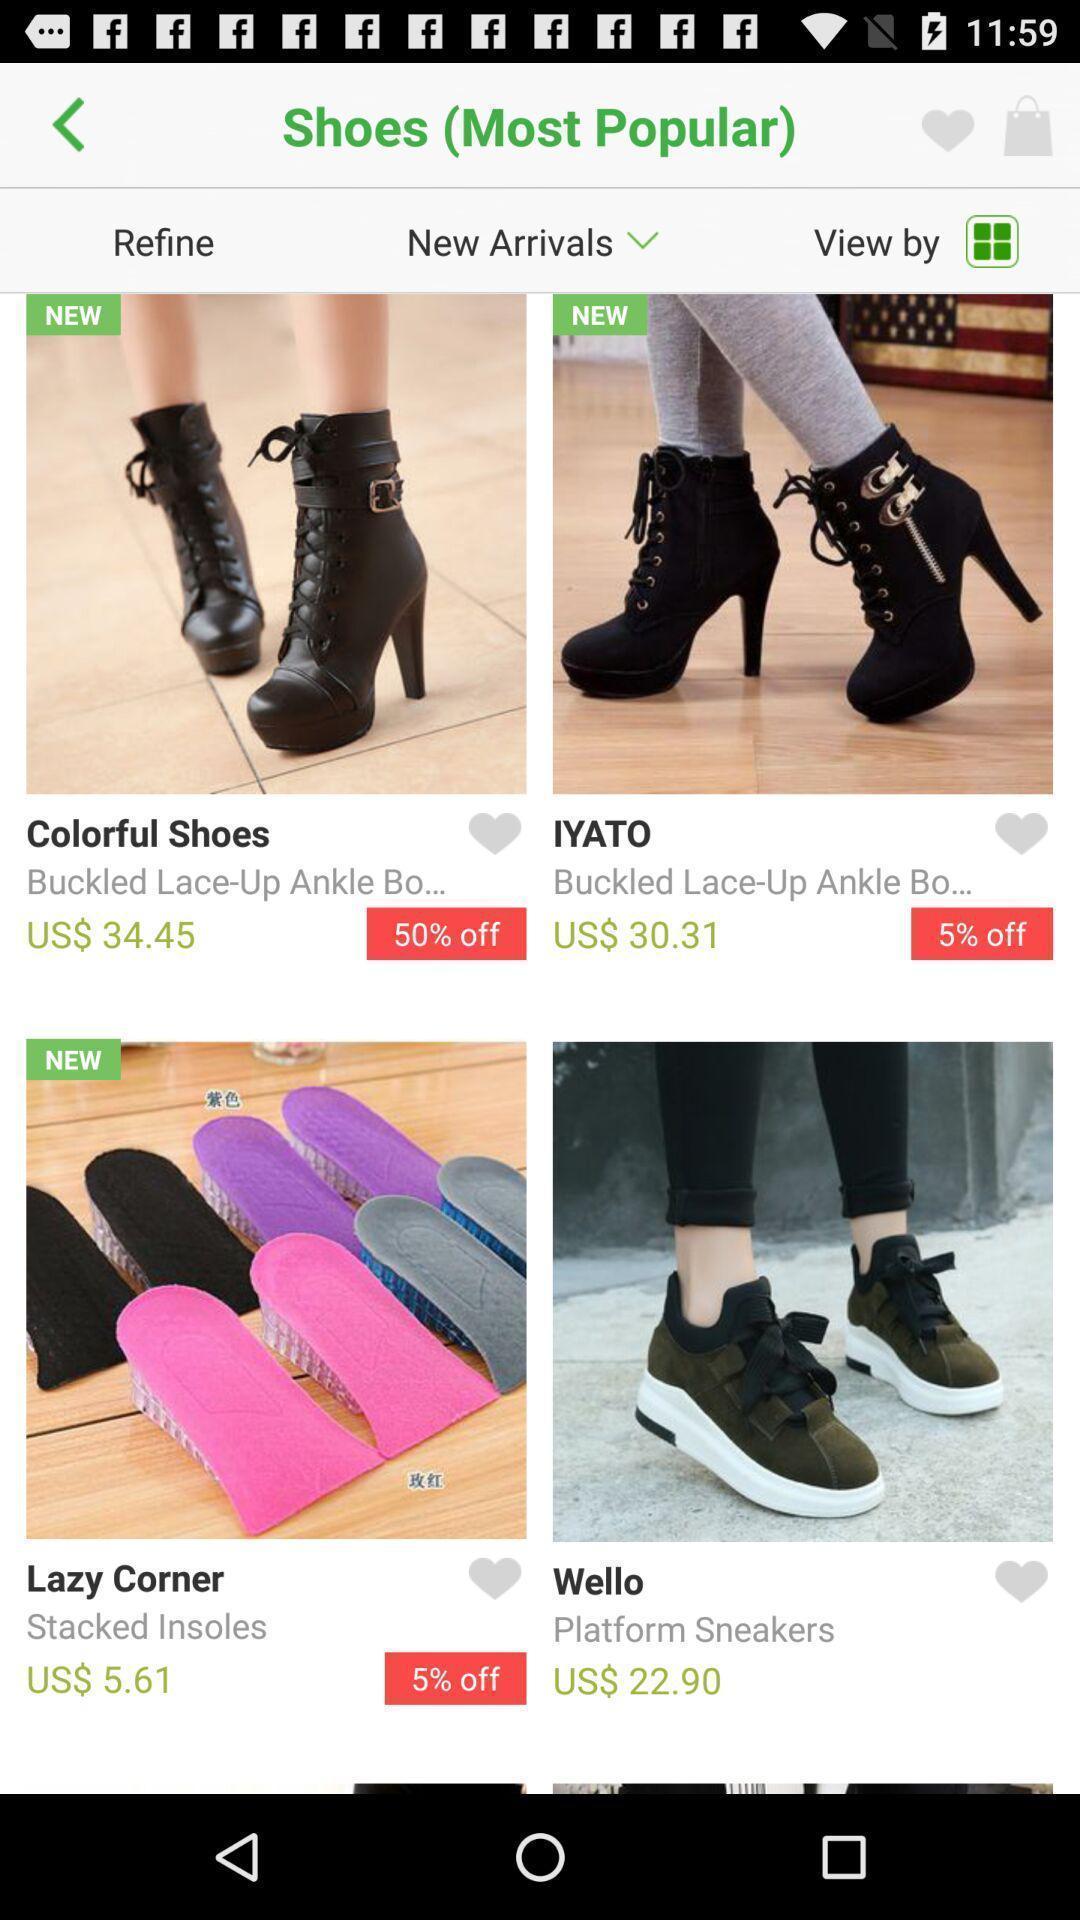Describe this image in words. Screen shows multiple products in a shopping application. 